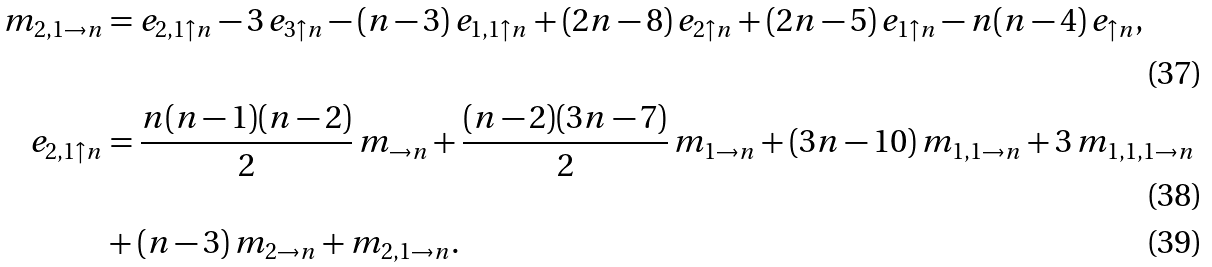<formula> <loc_0><loc_0><loc_500><loc_500>m _ { 2 , 1 \rightarrow n } & = e _ { 2 , 1 \uparrow n } - 3 \, e _ { 3 \uparrow n } - ( n - 3 ) \, e _ { 1 , 1 \uparrow n } + ( 2 n - 8 ) \, e _ { 2 \uparrow n } + ( 2 n - 5 ) \, e _ { 1 \uparrow n } - n ( n - 4 ) \, e _ { \uparrow n } , \\ e _ { 2 , 1 \uparrow n } & = \frac { n ( n - 1 ) ( n - 2 ) } { 2 } \, m _ { \rightarrow n } + \frac { ( n - 2 ) ( 3 n - 7 ) } { 2 } \, m _ { 1 \rightarrow n } + ( 3 n - 1 0 ) \, m _ { 1 , 1 \rightarrow n } + 3 \, m _ { 1 , 1 , 1 \rightarrow n } \\ & + ( n - 3 ) \, m _ { 2 \rightarrow n } + m _ { 2 , 1 \rightarrow n } .</formula> 